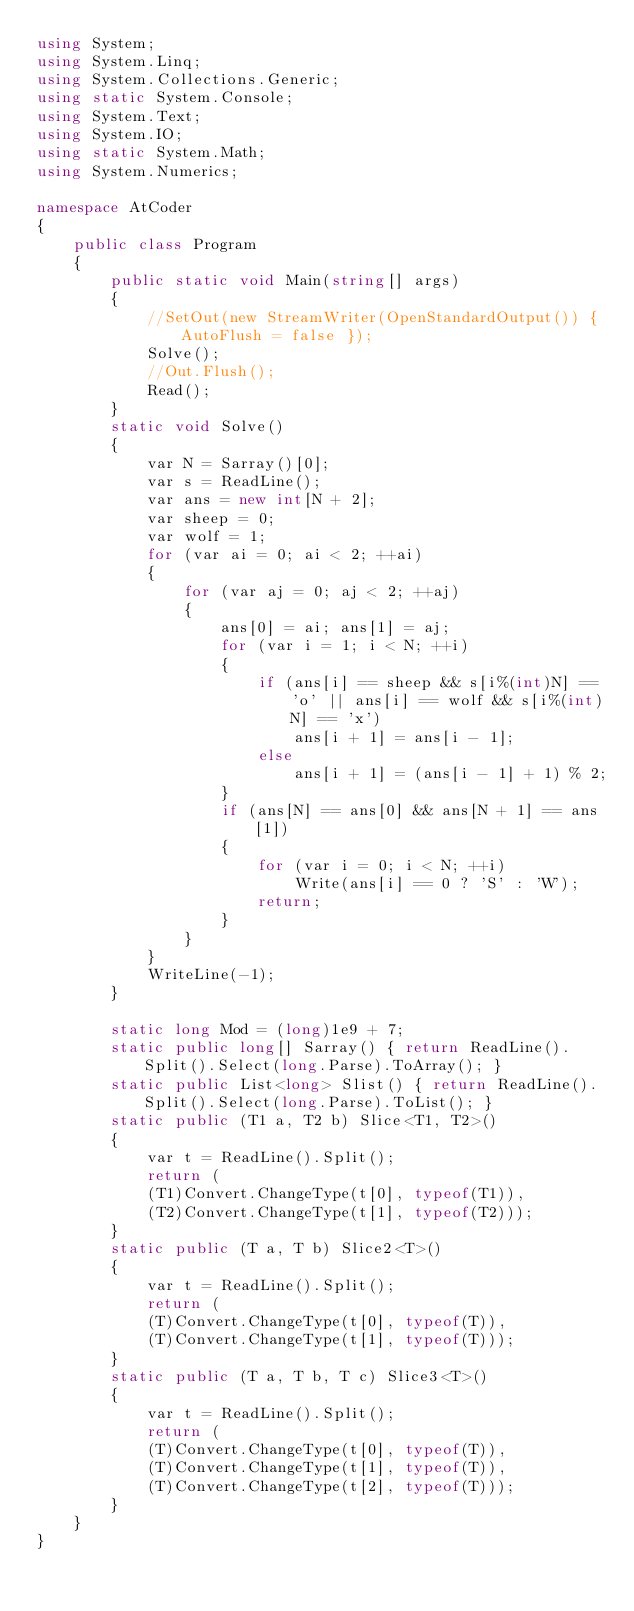<code> <loc_0><loc_0><loc_500><loc_500><_C#_>using System;
using System.Linq;
using System.Collections.Generic;
using static System.Console;
using System.Text;
using System.IO;
using static System.Math;
using System.Numerics;

namespace AtCoder
{
    public class Program
    {
        public static void Main(string[] args)
        {
            //SetOut(new StreamWriter(OpenStandardOutput()) { AutoFlush = false });
            Solve();
            //Out.Flush();
            Read();
        }
        static void Solve()
        {
            var N = Sarray()[0];
            var s = ReadLine();
            var ans = new int[N + 2];
            var sheep = 0;
            var wolf = 1;
            for (var ai = 0; ai < 2; ++ai)
            {
                for (var aj = 0; aj < 2; ++aj)
                {
                    ans[0] = ai; ans[1] = aj;
                    for (var i = 1; i < N; ++i)
                    {
                        if (ans[i] == sheep && s[i%(int)N] == 'o' || ans[i] == wolf && s[i%(int)N] == 'x')
                            ans[i + 1] = ans[i - 1];
                        else
                            ans[i + 1] = (ans[i - 1] + 1) % 2;
                    }
                    if (ans[N] == ans[0] && ans[N + 1] == ans[1])
                    {
                        for (var i = 0; i < N; ++i)
                            Write(ans[i] == 0 ? 'S' : 'W');
                        return;
                    }
                }
            }
            WriteLine(-1);
        }

        static long Mod = (long)1e9 + 7;
        static public long[] Sarray() { return ReadLine().Split().Select(long.Parse).ToArray(); }
        static public List<long> Slist() { return ReadLine().Split().Select(long.Parse).ToList(); }
        static public (T1 a, T2 b) Slice<T1, T2>()
        {
            var t = ReadLine().Split();
            return (
            (T1)Convert.ChangeType(t[0], typeof(T1)),
            (T2)Convert.ChangeType(t[1], typeof(T2)));
        }
        static public (T a, T b) Slice2<T>()
        {
            var t = ReadLine().Split();
            return (
            (T)Convert.ChangeType(t[0], typeof(T)),
            (T)Convert.ChangeType(t[1], typeof(T)));
        }
        static public (T a, T b, T c) Slice3<T>()
        {
            var t = ReadLine().Split();
            return (
            (T)Convert.ChangeType(t[0], typeof(T)),
            (T)Convert.ChangeType(t[1], typeof(T)),
            (T)Convert.ChangeType(t[2], typeof(T)));
        }
    }
}</code> 